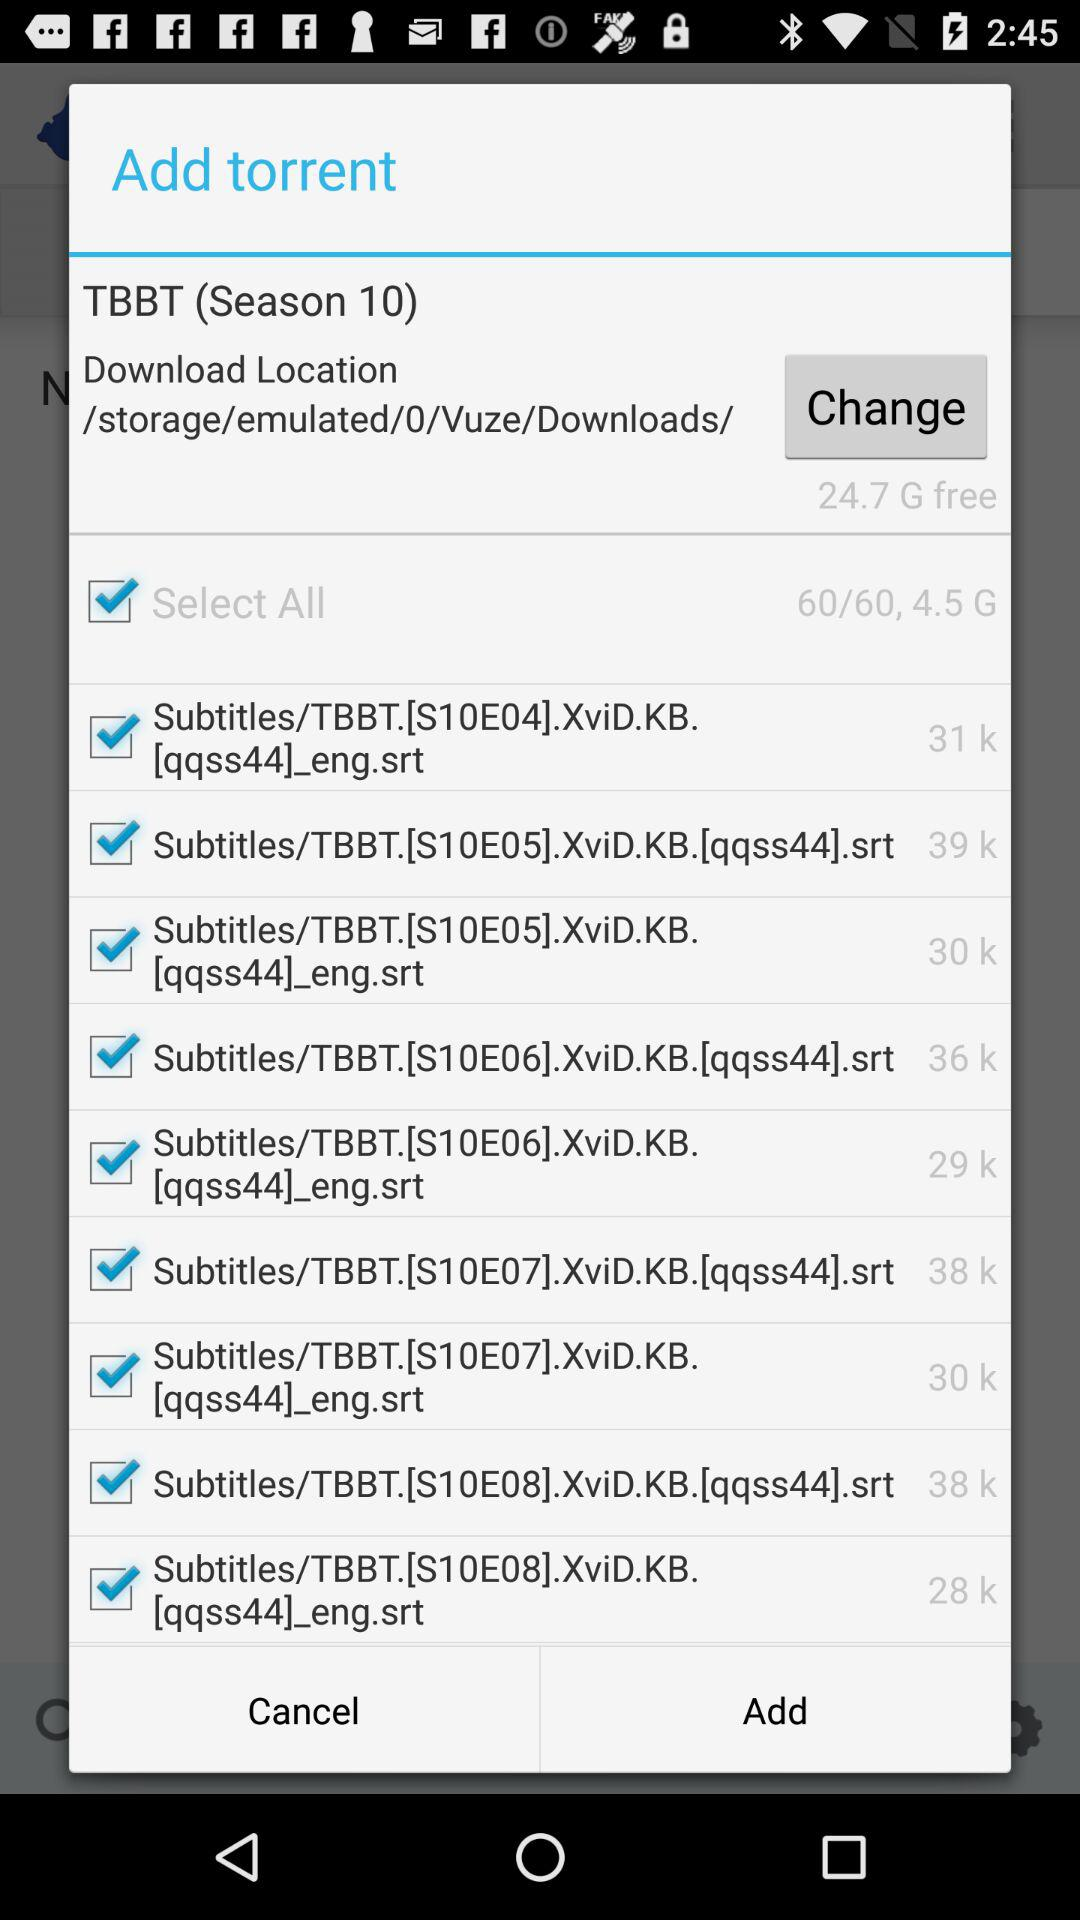What season of TBBT is there?
Answer the question using a single word or phrase. It's season 10. 